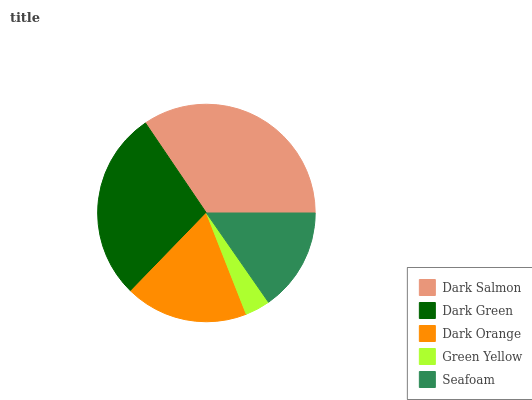Is Green Yellow the minimum?
Answer yes or no. Yes. Is Dark Salmon the maximum?
Answer yes or no. Yes. Is Dark Green the minimum?
Answer yes or no. No. Is Dark Green the maximum?
Answer yes or no. No. Is Dark Salmon greater than Dark Green?
Answer yes or no. Yes. Is Dark Green less than Dark Salmon?
Answer yes or no. Yes. Is Dark Green greater than Dark Salmon?
Answer yes or no. No. Is Dark Salmon less than Dark Green?
Answer yes or no. No. Is Dark Orange the high median?
Answer yes or no. Yes. Is Dark Orange the low median?
Answer yes or no. Yes. Is Seafoam the high median?
Answer yes or no. No. Is Dark Green the low median?
Answer yes or no. No. 